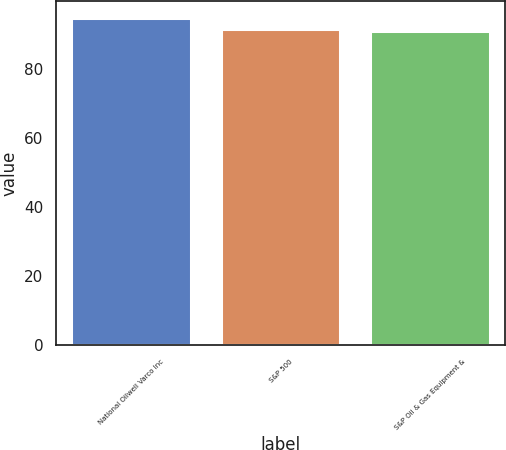Convert chart. <chart><loc_0><loc_0><loc_500><loc_500><bar_chart><fcel>National Oilwell Varco Inc<fcel>S&P 500<fcel>S&P Oil & Gas Equipment &<nl><fcel>94.77<fcel>91.67<fcel>90.86<nl></chart> 